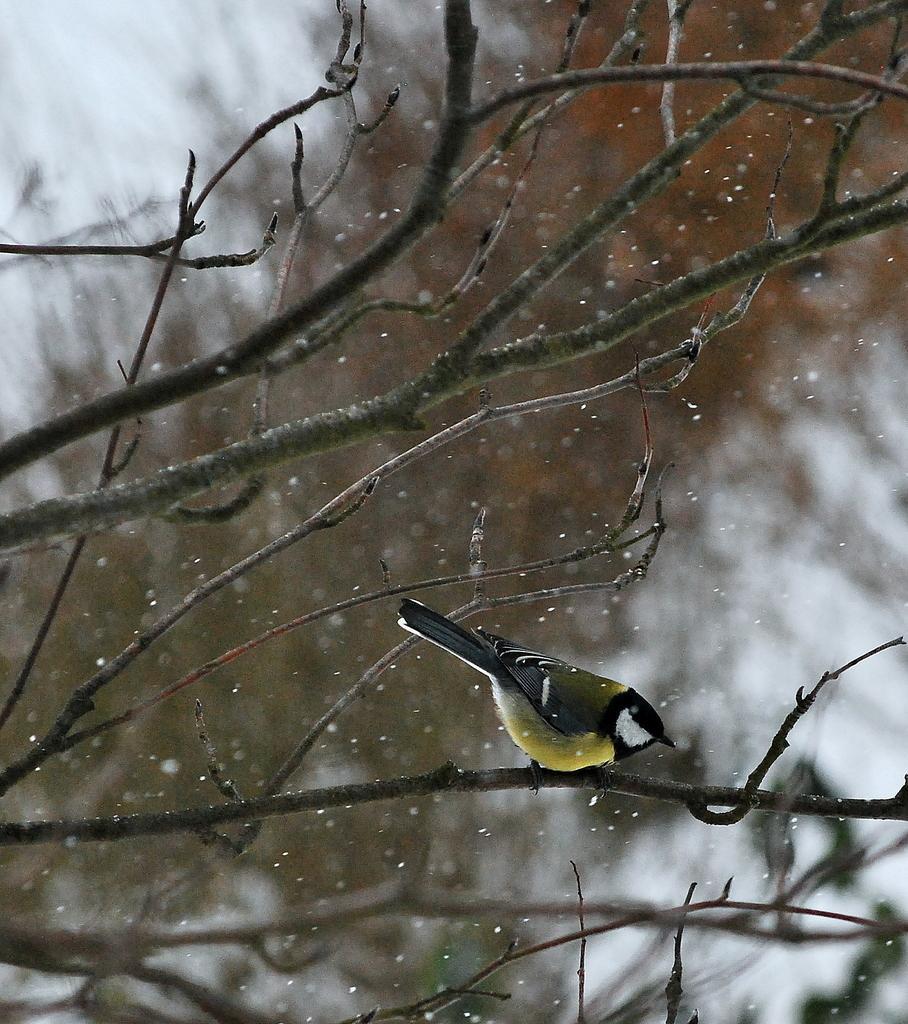Could you give a brief overview of what you see in this image? In this image we can see a bird on the branch, here is the snow, the background is blurry. 